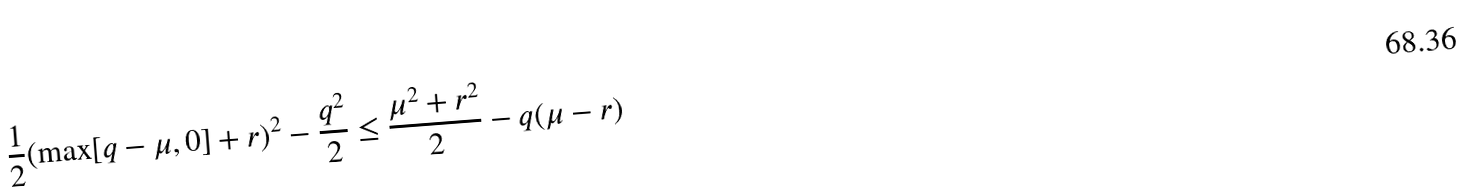Convert formula to latex. <formula><loc_0><loc_0><loc_500><loc_500>\frac { 1 } { 2 } ( \max [ q - \mu , 0 ] + r ) ^ { 2 } - \frac { q ^ { 2 } } { 2 } \leq \frac { \mu ^ { 2 } + r ^ { 2 } } { 2 } - q ( \mu - r )</formula> 